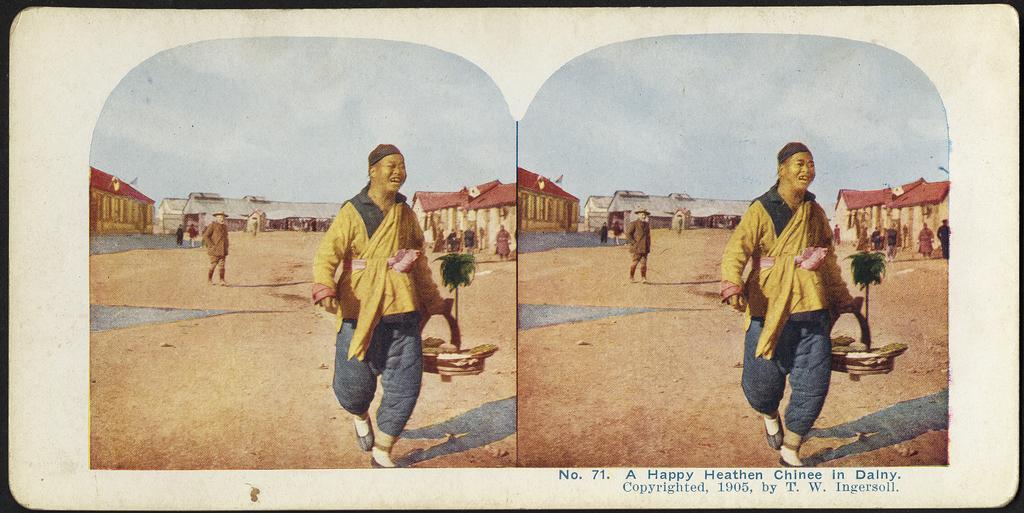Please provide a concise description of this image. This image is a photo. In this photo we can see a person wearing a yellow shirt is smiling and he is holding a basket in his hand. In the background we can see buildings, people and sky. 